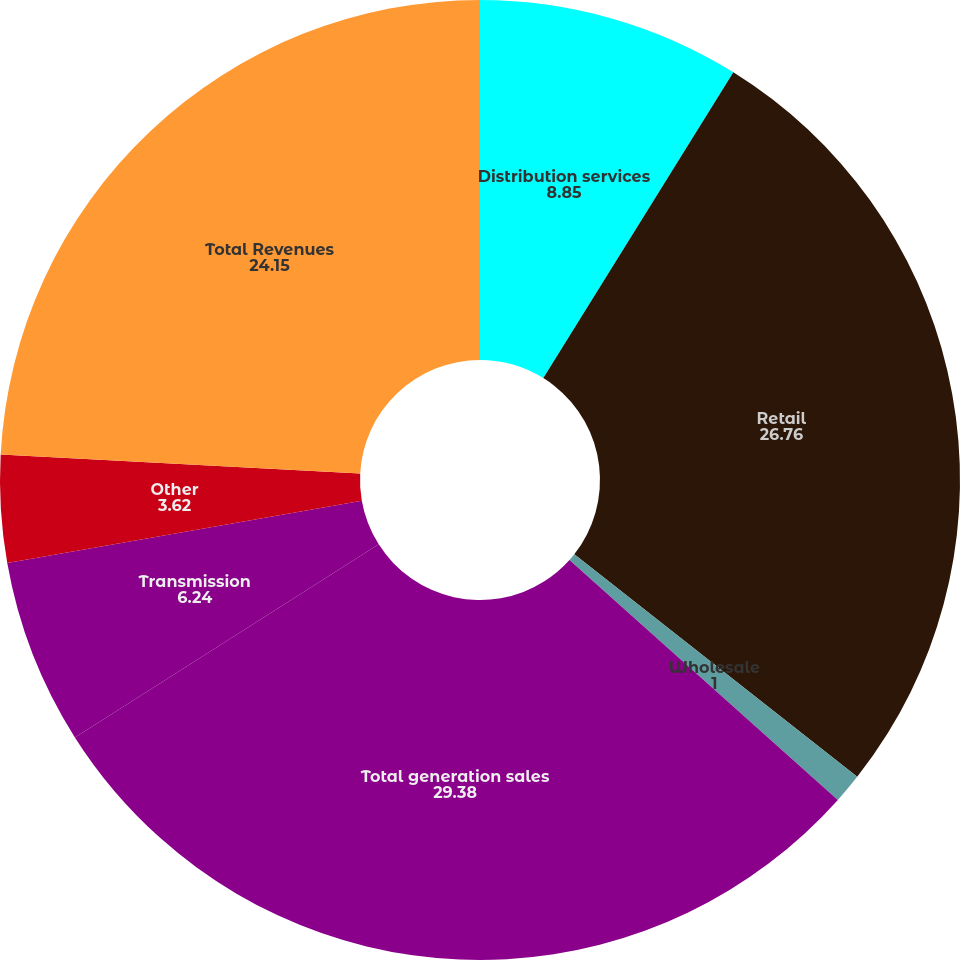<chart> <loc_0><loc_0><loc_500><loc_500><pie_chart><fcel>Distribution services<fcel>Retail<fcel>Wholesale<fcel>Total generation sales<fcel>Transmission<fcel>Other<fcel>Total Revenues<nl><fcel>8.85%<fcel>26.76%<fcel>1.0%<fcel>29.38%<fcel>6.24%<fcel>3.62%<fcel>24.15%<nl></chart> 